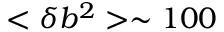Convert formula to latex. <formula><loc_0><loc_0><loc_500><loc_500>< \delta b ^ { 2 } > \sim 1 0 0</formula> 